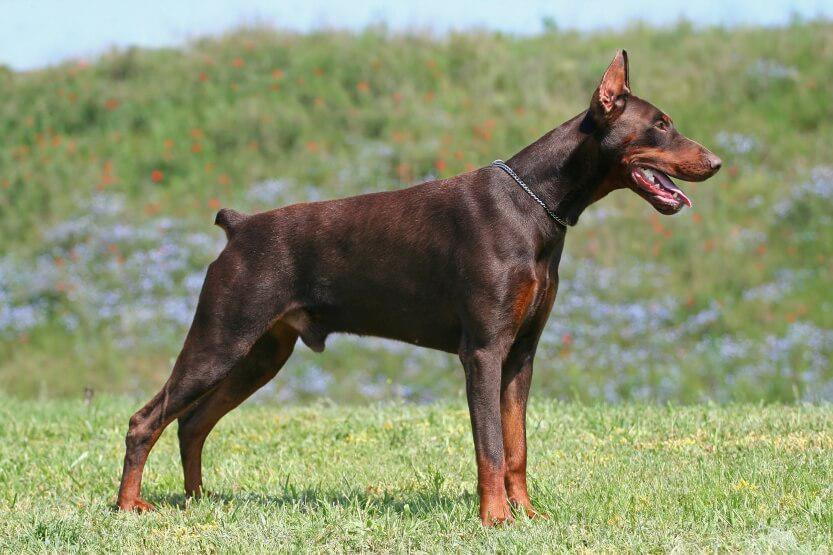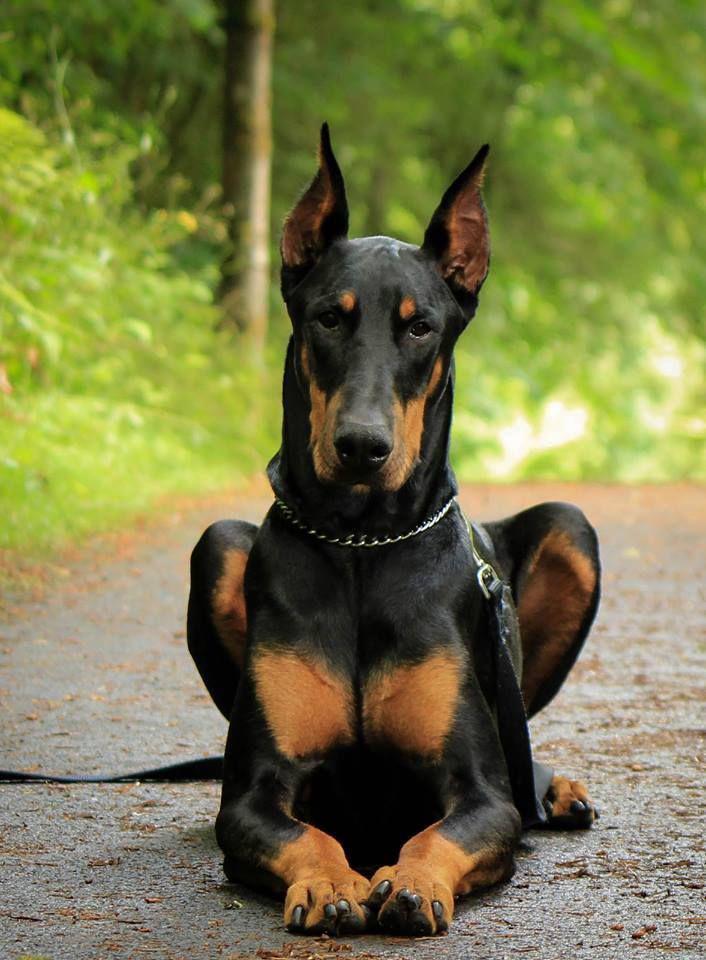The first image is the image on the left, the second image is the image on the right. Considering the images on both sides, is "Three dogs are sitting in the grass in one of the images." valid? Answer yes or no. No. The first image is the image on the left, the second image is the image on the right. For the images shown, is this caption "There are four dogs." true? Answer yes or no. No. 